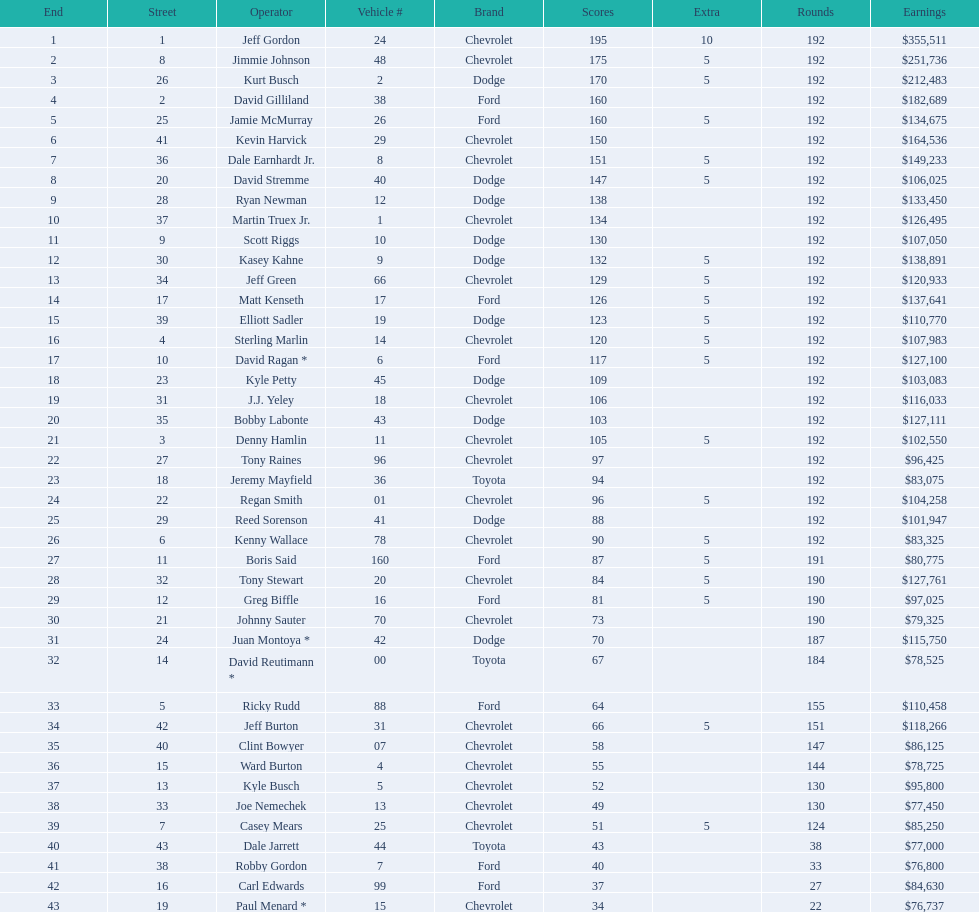How many drivers placed below tony stewart? 15. 